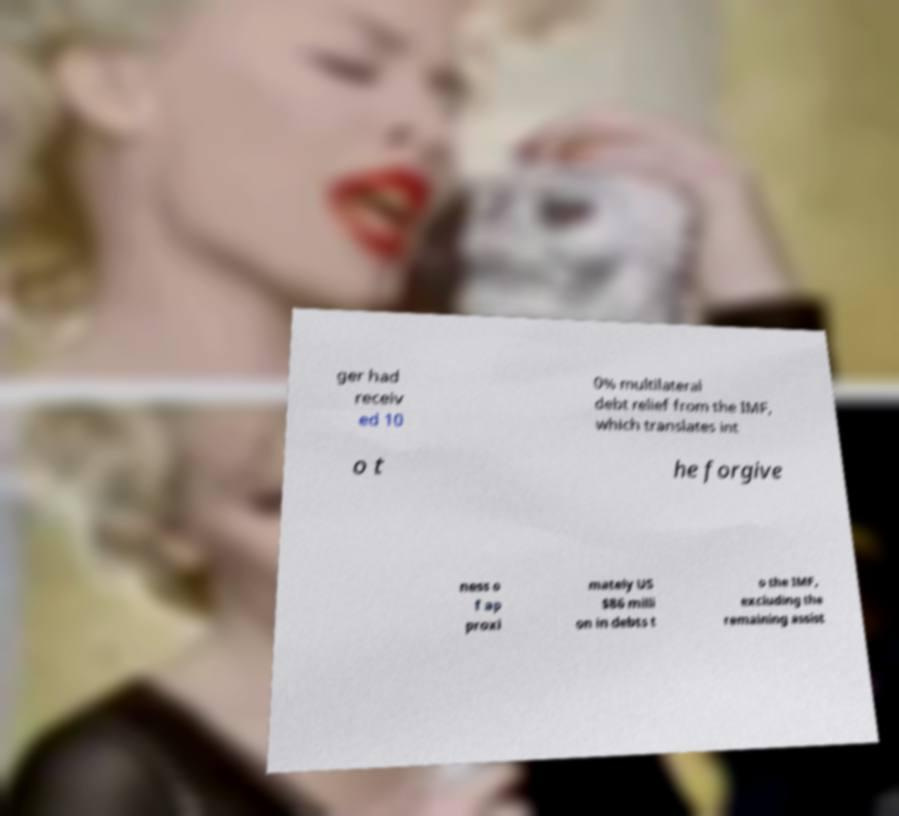Can you accurately transcribe the text from the provided image for me? ger had receiv ed 10 0% multilateral debt relief from the IMF, which translates int o t he forgive ness o f ap proxi mately US $86 milli on in debts t o the IMF, excluding the remaining assist 